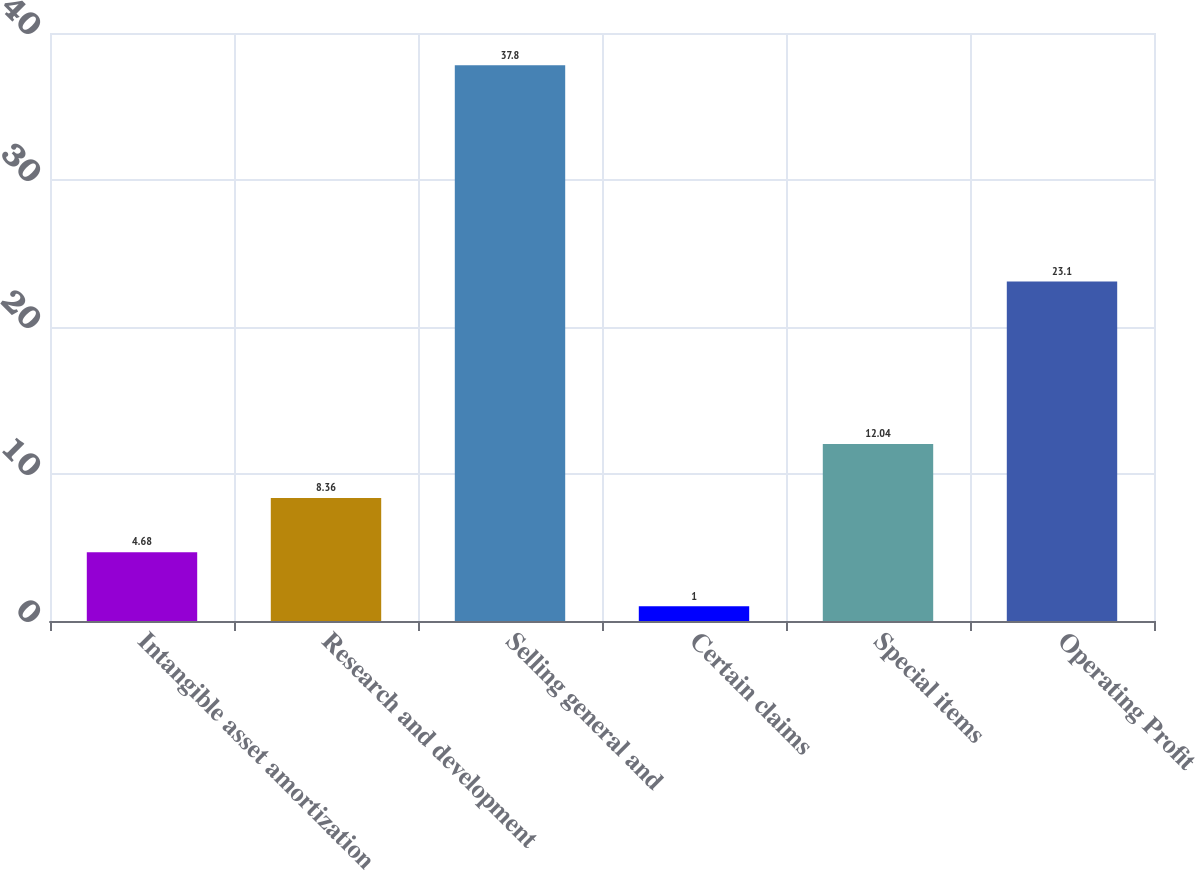Convert chart to OTSL. <chart><loc_0><loc_0><loc_500><loc_500><bar_chart><fcel>Intangible asset amortization<fcel>Research and development<fcel>Selling general and<fcel>Certain claims<fcel>Special items<fcel>Operating Profit<nl><fcel>4.68<fcel>8.36<fcel>37.8<fcel>1<fcel>12.04<fcel>23.1<nl></chart> 